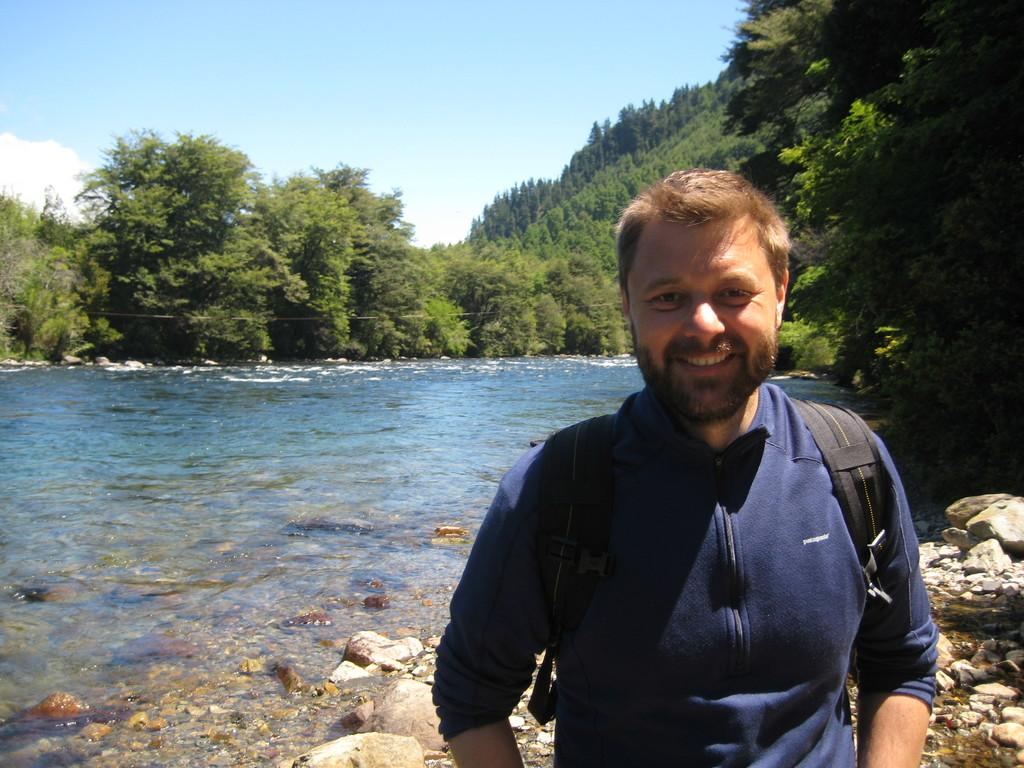Who is present in the image? There is a man in the image. What is the man doing in the image? The man is smiling in the image. What is the man standing on? The man is standing on stones in the image. What can be seen in the background of the image? Sky, clouds, trees, and water are visible in the background of the image. What is present under the water in the image? Stones are present under the water in the image. What type of bell can be heard ringing in the image? There is no bell present or ringing in the image. What game is the man playing with the rail in the image? There is no rail or game being played in the image. 